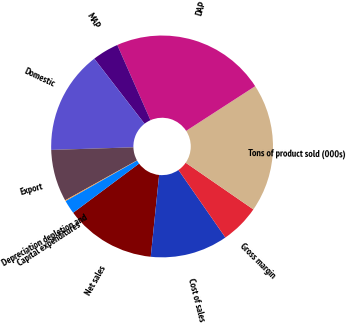<chart> <loc_0><loc_0><loc_500><loc_500><pie_chart><fcel>Net sales<fcel>Cost of sales<fcel>Gross margin<fcel>Tons of product sold (000s)<fcel>DAP<fcel>MAP<fcel>Domestic<fcel>Export<fcel>Depreciation depletion and<fcel>Capital expenditures<nl><fcel>13.17%<fcel>11.3%<fcel>5.72%<fcel>18.75%<fcel>22.48%<fcel>3.85%<fcel>15.03%<fcel>7.58%<fcel>0.13%<fcel>1.99%<nl></chart> 